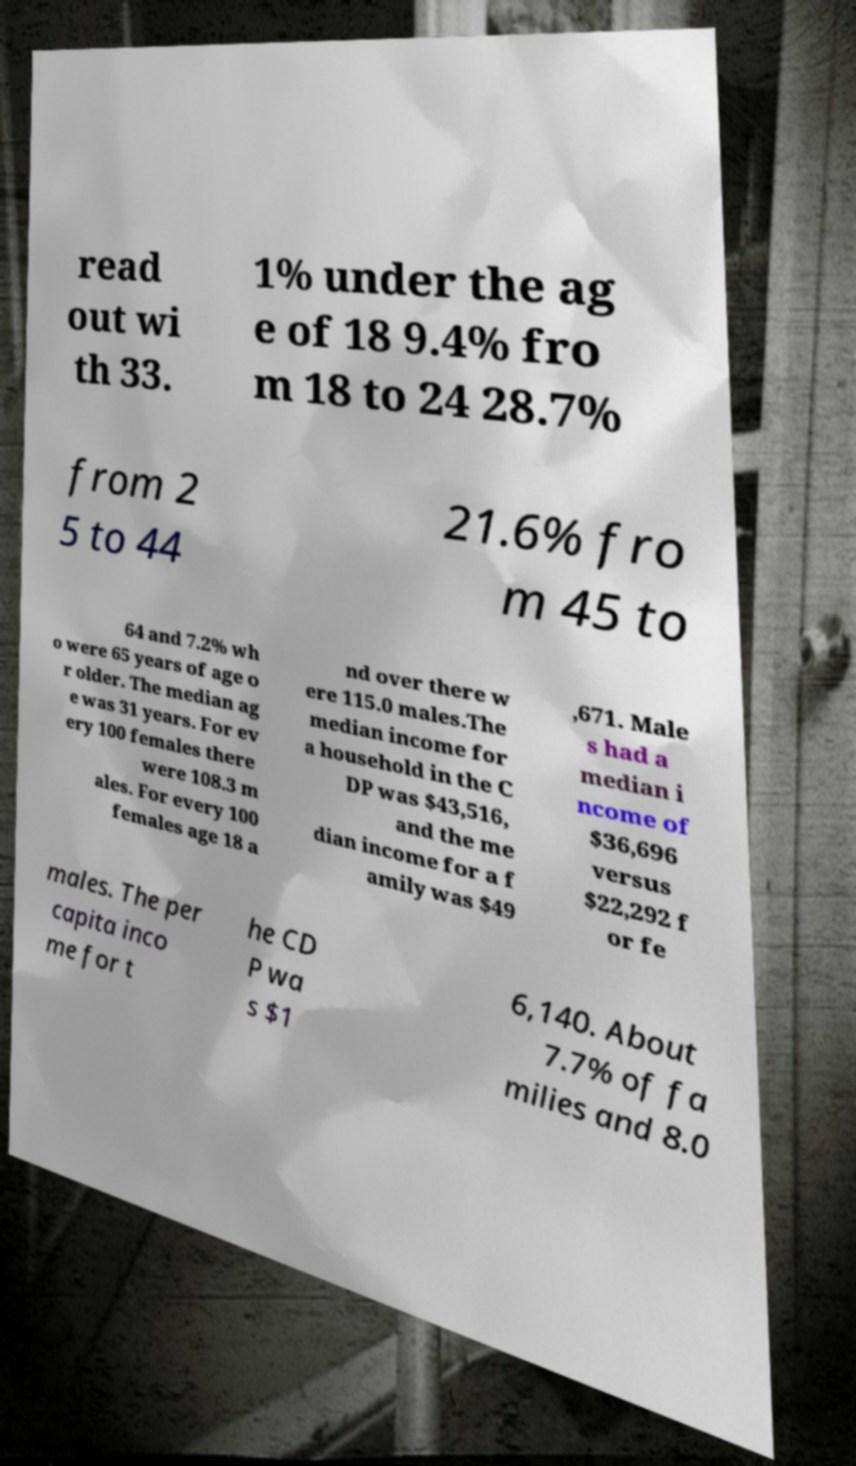What messages or text are displayed in this image? I need them in a readable, typed format. read out wi th 33. 1% under the ag e of 18 9.4% fro m 18 to 24 28.7% from 2 5 to 44 21.6% fro m 45 to 64 and 7.2% wh o were 65 years of age o r older. The median ag e was 31 years. For ev ery 100 females there were 108.3 m ales. For every 100 females age 18 a nd over there w ere 115.0 males.The median income for a household in the C DP was $43,516, and the me dian income for a f amily was $49 ,671. Male s had a median i ncome of $36,696 versus $22,292 f or fe males. The per capita inco me for t he CD P wa s $1 6,140. About 7.7% of fa milies and 8.0 